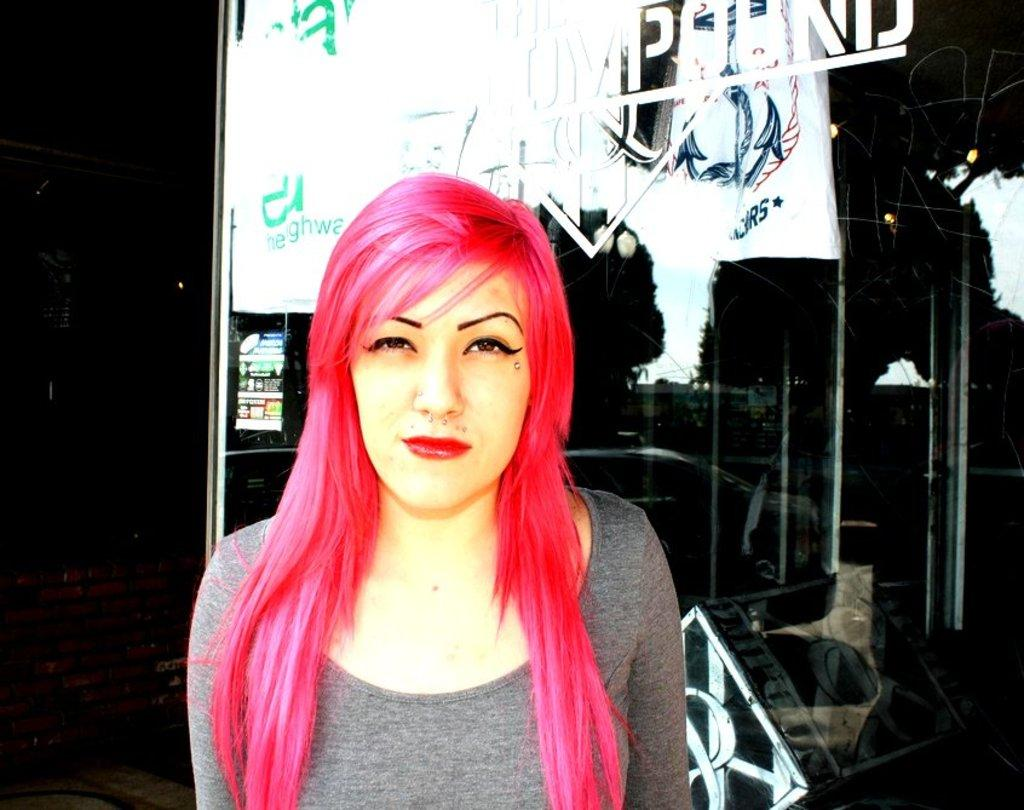What type of image is being described? The image is animated. Can you describe the appearance of one of the characters in the image? There is a woman with pink hair in the image. What can be seen in the background of the image? There is a board in the background of the image. What is the color of the background in the image? The background color is black. How many pies are being tested by the woman with pink hair in the image? There are no pies present in the image, and the woman with pink hair is not testing anything. 